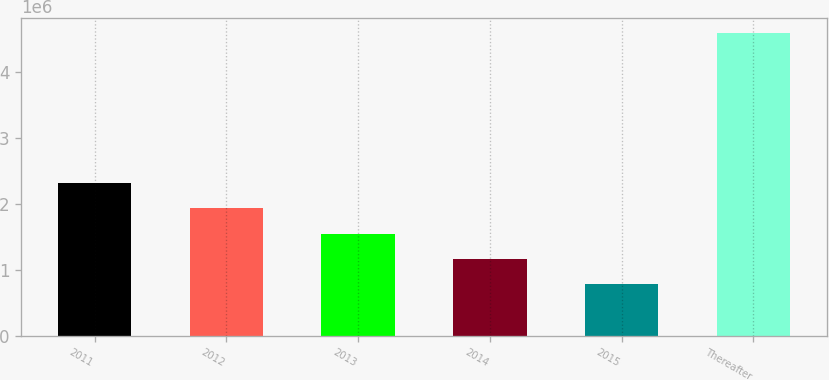Convert chart to OTSL. <chart><loc_0><loc_0><loc_500><loc_500><bar_chart><fcel>2011<fcel>2012<fcel>2013<fcel>2014<fcel>2015<fcel>Thereafter<nl><fcel>2.31404e+06<fcel>1.93288e+06<fcel>1.55172e+06<fcel>1.17056e+06<fcel>789405<fcel>4.601e+06<nl></chart> 